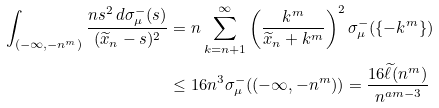<formula> <loc_0><loc_0><loc_500><loc_500>\int _ { ( - \infty , - n ^ { m } ) } \frac { n s ^ { 2 } \, d \sigma _ { \mu } ^ { - } ( s ) } { ( \widetilde { x } _ { n } - s ) ^ { 2 } } & = n \sum _ { k = n + 1 } ^ { \infty } \left ( \frac { k ^ { m } } { \widetilde { x } _ { n } + k ^ { m } } \right ) ^ { 2 } \sigma _ { \mu } ^ { - } ( \{ - k ^ { m } \} ) \\ & \leq 1 6 n ^ { 3 } \sigma _ { \mu } ^ { - } ( ( - \infty , - n ^ { m } ) ) = \frac { 1 6 \widetilde { \ell } ( n ^ { m } ) } { n ^ { a m - 3 } }</formula> 